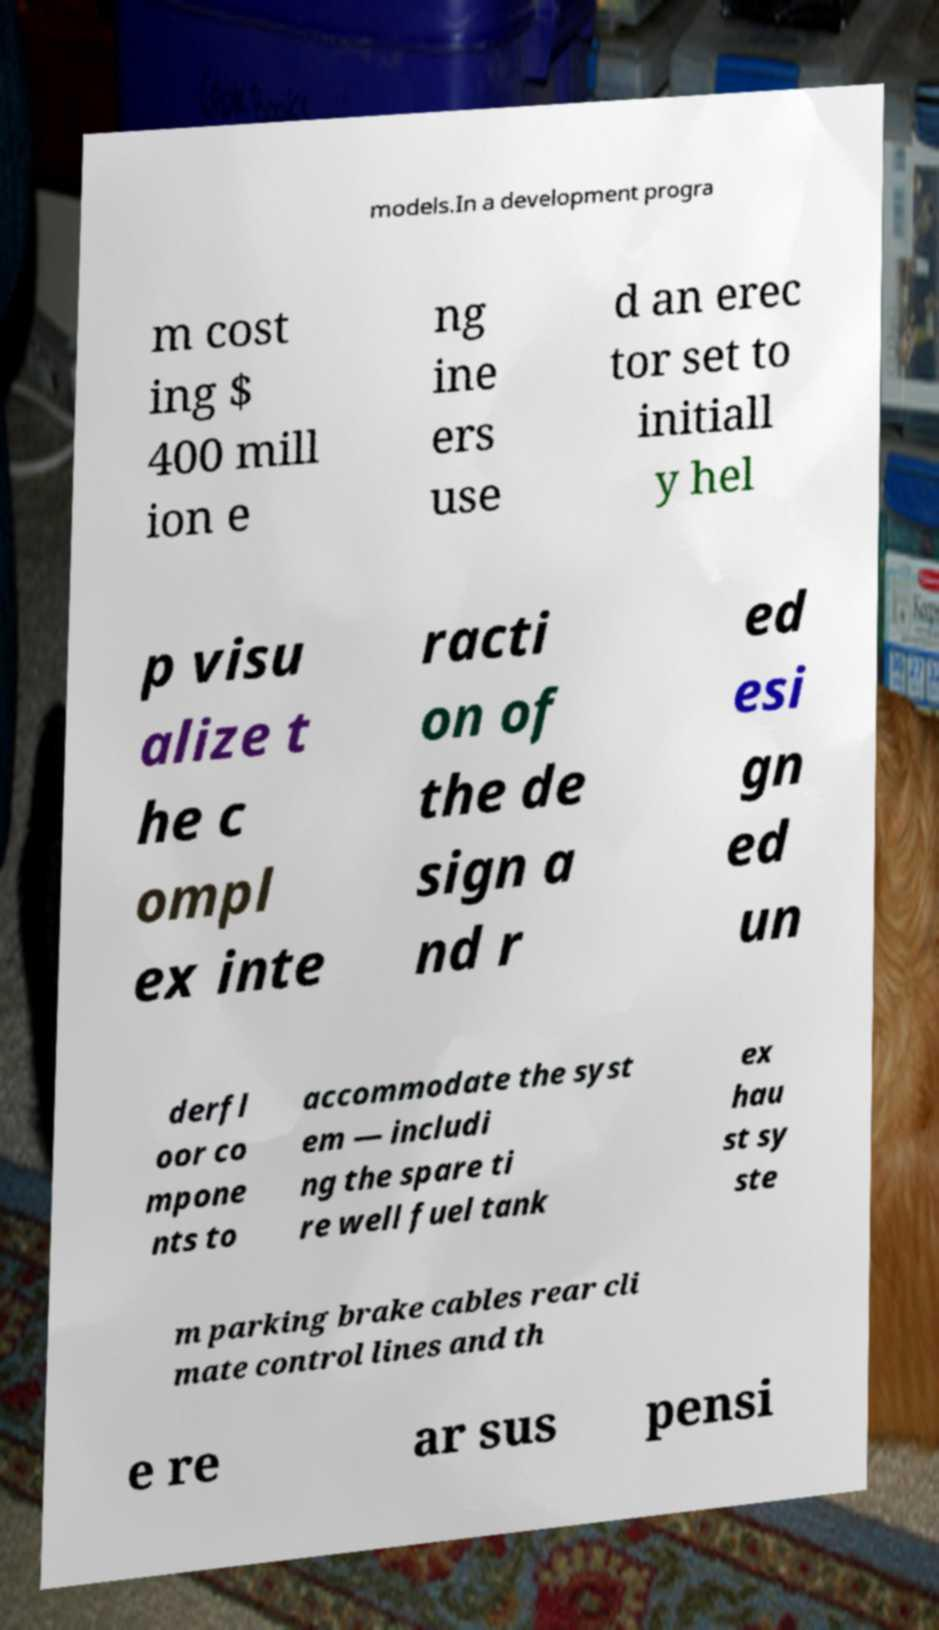Please read and relay the text visible in this image. What does it say? models.In a development progra m cost ing $ 400 mill ion e ng ine ers use d an erec tor set to initiall y hel p visu alize t he c ompl ex inte racti on of the de sign a nd r ed esi gn ed un derfl oor co mpone nts to accommodate the syst em — includi ng the spare ti re well fuel tank ex hau st sy ste m parking brake cables rear cli mate control lines and th e re ar sus pensi 